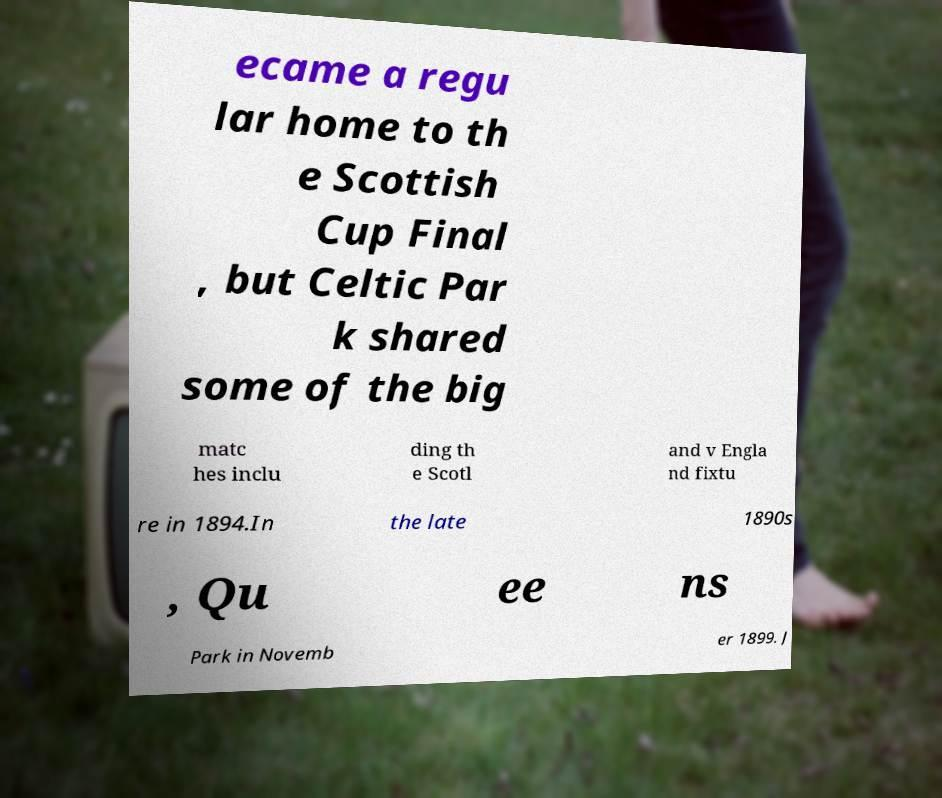Please identify and transcribe the text found in this image. ecame a regu lar home to th e Scottish Cup Final , but Celtic Par k shared some of the big matc hes inclu ding th e Scotl and v Engla nd fixtu re in 1894.In the late 1890s , Qu ee ns Park in Novemb er 1899. J 